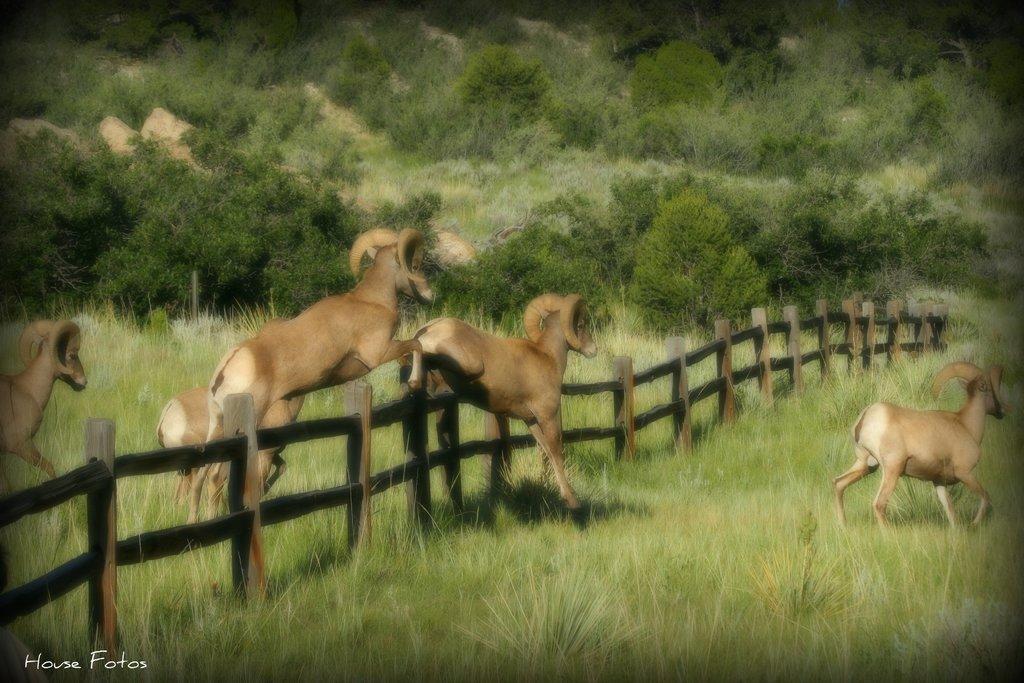In one or two sentences, can you explain what this image depicts? In this image we can see many trees and plants. There is a grassy land in the image. There are few animals in the image. There is a fencing in the image. 